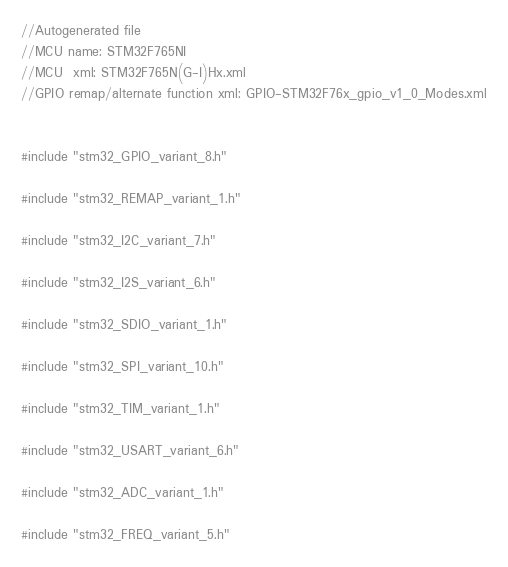<code> <loc_0><loc_0><loc_500><loc_500><_C_>//Autogenerated file
//MCU name: STM32F765NI
//MCU  xml: STM32F765N(G-I)Hx.xml
//GPIO remap/alternate function xml: GPIO-STM32F76x_gpio_v1_0_Modes.xml


#include "stm32_GPIO_variant_8.h"

#include "stm32_REMAP_variant_1.h"

#include "stm32_I2C_variant_7.h"

#include "stm32_I2S_variant_6.h"

#include "stm32_SDIO_variant_1.h"

#include "stm32_SPI_variant_10.h"

#include "stm32_TIM_variant_1.h"

#include "stm32_USART_variant_6.h"

#include "stm32_ADC_variant_1.h"

#include "stm32_FREQ_variant_5.h"

</code> 